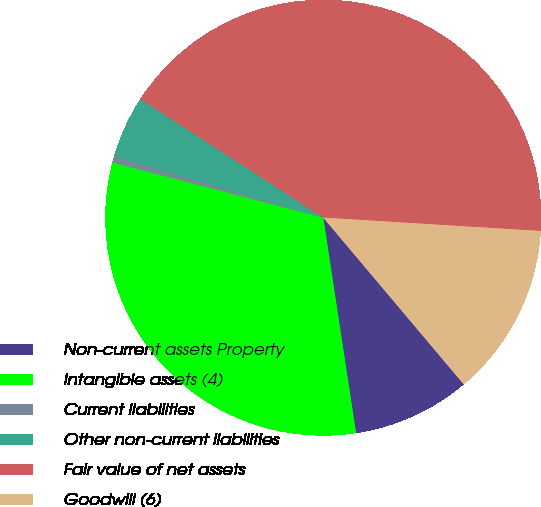Convert chart. <chart><loc_0><loc_0><loc_500><loc_500><pie_chart><fcel>Non-current assets Property<fcel>Intangible assets (4)<fcel>Current liabilities<fcel>Other non-current liabilities<fcel>Fair value of net assets<fcel>Goodwill (6)<nl><fcel>8.74%<fcel>31.48%<fcel>0.47%<fcel>4.61%<fcel>41.82%<fcel>12.88%<nl></chart> 